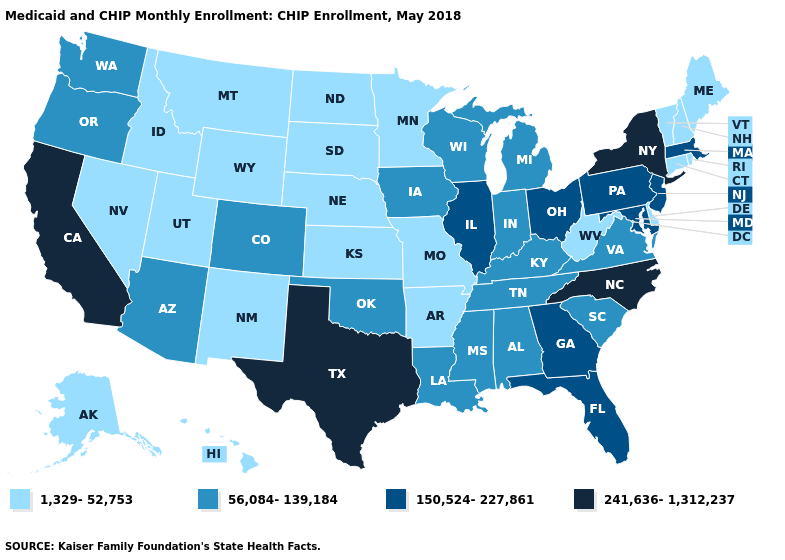Name the states that have a value in the range 241,636-1,312,237?
Concise answer only. California, New York, North Carolina, Texas. What is the value of Wyoming?
Short answer required. 1,329-52,753. Which states have the lowest value in the West?
Answer briefly. Alaska, Hawaii, Idaho, Montana, Nevada, New Mexico, Utah, Wyoming. What is the highest value in the Northeast ?
Write a very short answer. 241,636-1,312,237. Does Missouri have the same value as Alaska?
Give a very brief answer. Yes. What is the value of Connecticut?
Write a very short answer. 1,329-52,753. Name the states that have a value in the range 56,084-139,184?
Be succinct. Alabama, Arizona, Colorado, Indiana, Iowa, Kentucky, Louisiana, Michigan, Mississippi, Oklahoma, Oregon, South Carolina, Tennessee, Virginia, Washington, Wisconsin. What is the value of New Jersey?
Write a very short answer. 150,524-227,861. Does Kansas have the highest value in the MidWest?
Be succinct. No. What is the value of Nebraska?
Short answer required. 1,329-52,753. What is the value of California?
Quick response, please. 241,636-1,312,237. How many symbols are there in the legend?
Concise answer only. 4. Which states have the lowest value in the MidWest?
Write a very short answer. Kansas, Minnesota, Missouri, Nebraska, North Dakota, South Dakota. Does California have the lowest value in the USA?
Keep it brief. No. Which states have the lowest value in the South?
Write a very short answer. Arkansas, Delaware, West Virginia. 